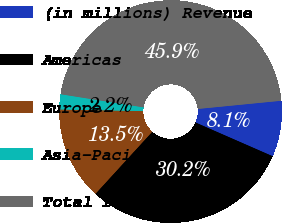Convert chart to OTSL. <chart><loc_0><loc_0><loc_500><loc_500><pie_chart><fcel>(in millions) Revenue<fcel>Americas<fcel>Europe<fcel>Asia-Pacific<fcel>Total revenue<nl><fcel>8.12%<fcel>30.23%<fcel>13.52%<fcel>2.19%<fcel>45.94%<nl></chart> 